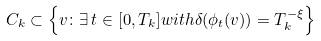<formula> <loc_0><loc_0><loc_500><loc_500>C _ { k } \subset \left \{ v \colon \exists \, t \in [ 0 , T _ { k } ] w i t h \delta ( \phi _ { t } ( v ) ) = T _ { k } ^ { - \xi } \right \}</formula> 